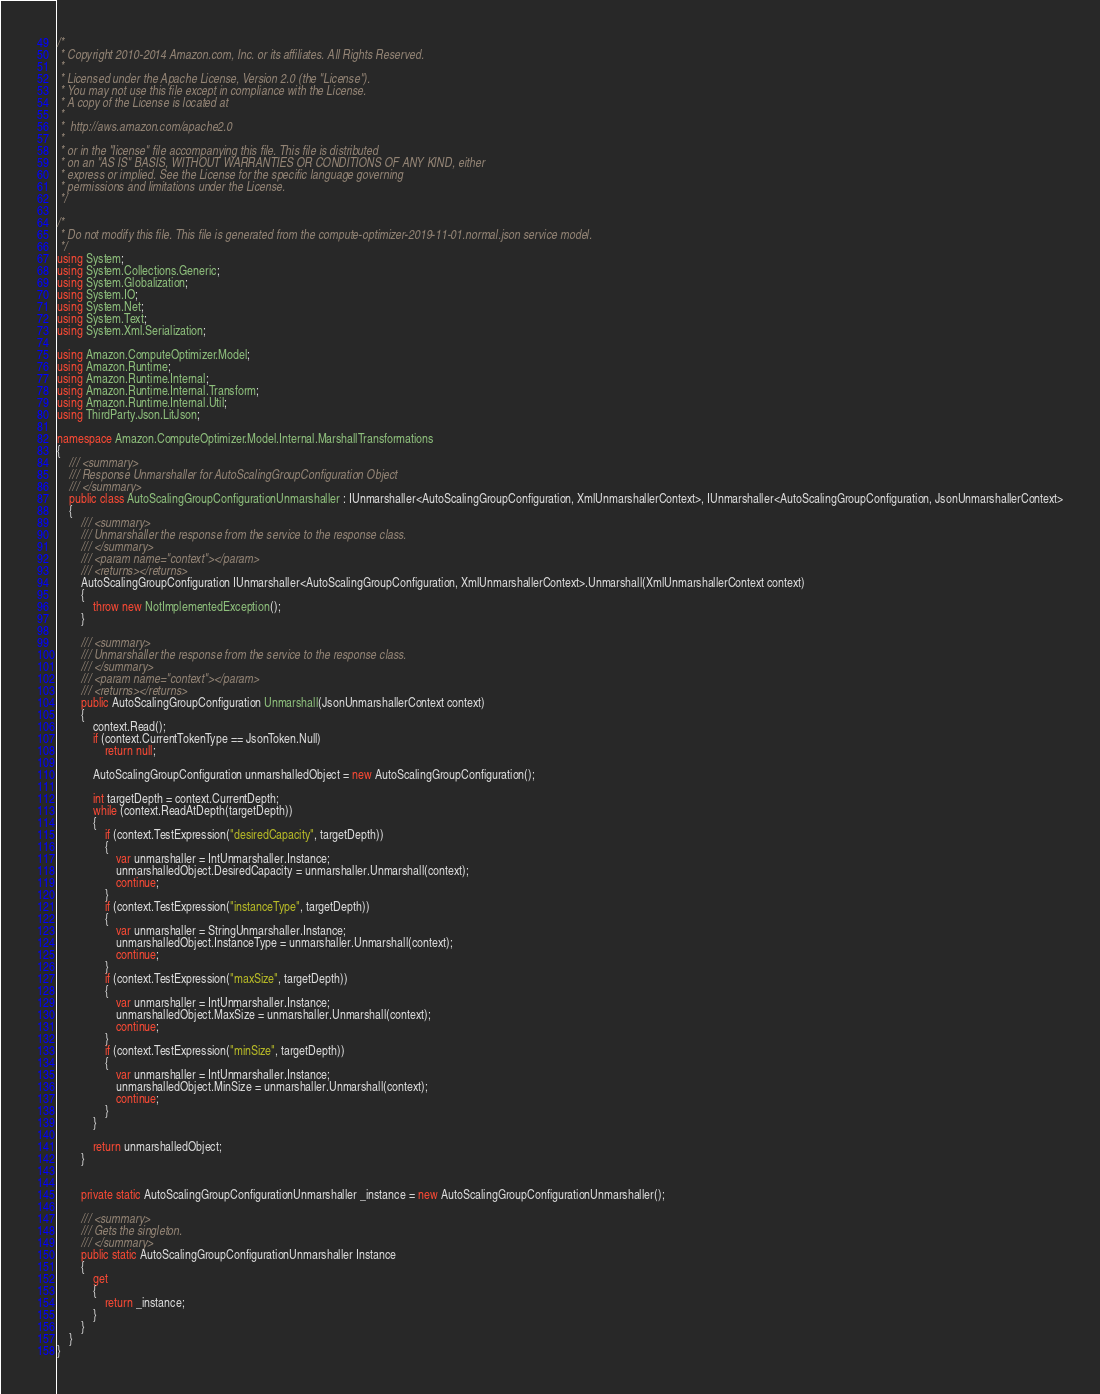Convert code to text. <code><loc_0><loc_0><loc_500><loc_500><_C#_>/*
 * Copyright 2010-2014 Amazon.com, Inc. or its affiliates. All Rights Reserved.
 * 
 * Licensed under the Apache License, Version 2.0 (the "License").
 * You may not use this file except in compliance with the License.
 * A copy of the License is located at
 * 
 *  http://aws.amazon.com/apache2.0
 * 
 * or in the "license" file accompanying this file. This file is distributed
 * on an "AS IS" BASIS, WITHOUT WARRANTIES OR CONDITIONS OF ANY KIND, either
 * express or implied. See the License for the specific language governing
 * permissions and limitations under the License.
 */

/*
 * Do not modify this file. This file is generated from the compute-optimizer-2019-11-01.normal.json service model.
 */
using System;
using System.Collections.Generic;
using System.Globalization;
using System.IO;
using System.Net;
using System.Text;
using System.Xml.Serialization;

using Amazon.ComputeOptimizer.Model;
using Amazon.Runtime;
using Amazon.Runtime.Internal;
using Amazon.Runtime.Internal.Transform;
using Amazon.Runtime.Internal.Util;
using ThirdParty.Json.LitJson;

namespace Amazon.ComputeOptimizer.Model.Internal.MarshallTransformations
{
    /// <summary>
    /// Response Unmarshaller for AutoScalingGroupConfiguration Object
    /// </summary>  
    public class AutoScalingGroupConfigurationUnmarshaller : IUnmarshaller<AutoScalingGroupConfiguration, XmlUnmarshallerContext>, IUnmarshaller<AutoScalingGroupConfiguration, JsonUnmarshallerContext>
    {
        /// <summary>
        /// Unmarshaller the response from the service to the response class.
        /// </summary>  
        /// <param name="context"></param>
        /// <returns></returns>
        AutoScalingGroupConfiguration IUnmarshaller<AutoScalingGroupConfiguration, XmlUnmarshallerContext>.Unmarshall(XmlUnmarshallerContext context)
        {
            throw new NotImplementedException();
        }

        /// <summary>
        /// Unmarshaller the response from the service to the response class.
        /// </summary>  
        /// <param name="context"></param>
        /// <returns></returns>
        public AutoScalingGroupConfiguration Unmarshall(JsonUnmarshallerContext context)
        {
            context.Read();
            if (context.CurrentTokenType == JsonToken.Null) 
                return null;

            AutoScalingGroupConfiguration unmarshalledObject = new AutoScalingGroupConfiguration();
        
            int targetDepth = context.CurrentDepth;
            while (context.ReadAtDepth(targetDepth))
            {
                if (context.TestExpression("desiredCapacity", targetDepth))
                {
                    var unmarshaller = IntUnmarshaller.Instance;
                    unmarshalledObject.DesiredCapacity = unmarshaller.Unmarshall(context);
                    continue;
                }
                if (context.TestExpression("instanceType", targetDepth))
                {
                    var unmarshaller = StringUnmarshaller.Instance;
                    unmarshalledObject.InstanceType = unmarshaller.Unmarshall(context);
                    continue;
                }
                if (context.TestExpression("maxSize", targetDepth))
                {
                    var unmarshaller = IntUnmarshaller.Instance;
                    unmarshalledObject.MaxSize = unmarshaller.Unmarshall(context);
                    continue;
                }
                if (context.TestExpression("minSize", targetDepth))
                {
                    var unmarshaller = IntUnmarshaller.Instance;
                    unmarshalledObject.MinSize = unmarshaller.Unmarshall(context);
                    continue;
                }
            }
          
            return unmarshalledObject;
        }


        private static AutoScalingGroupConfigurationUnmarshaller _instance = new AutoScalingGroupConfigurationUnmarshaller();        

        /// <summary>
        /// Gets the singleton.
        /// </summary>  
        public static AutoScalingGroupConfigurationUnmarshaller Instance
        {
            get
            {
                return _instance;
            }
        }
    }
}</code> 